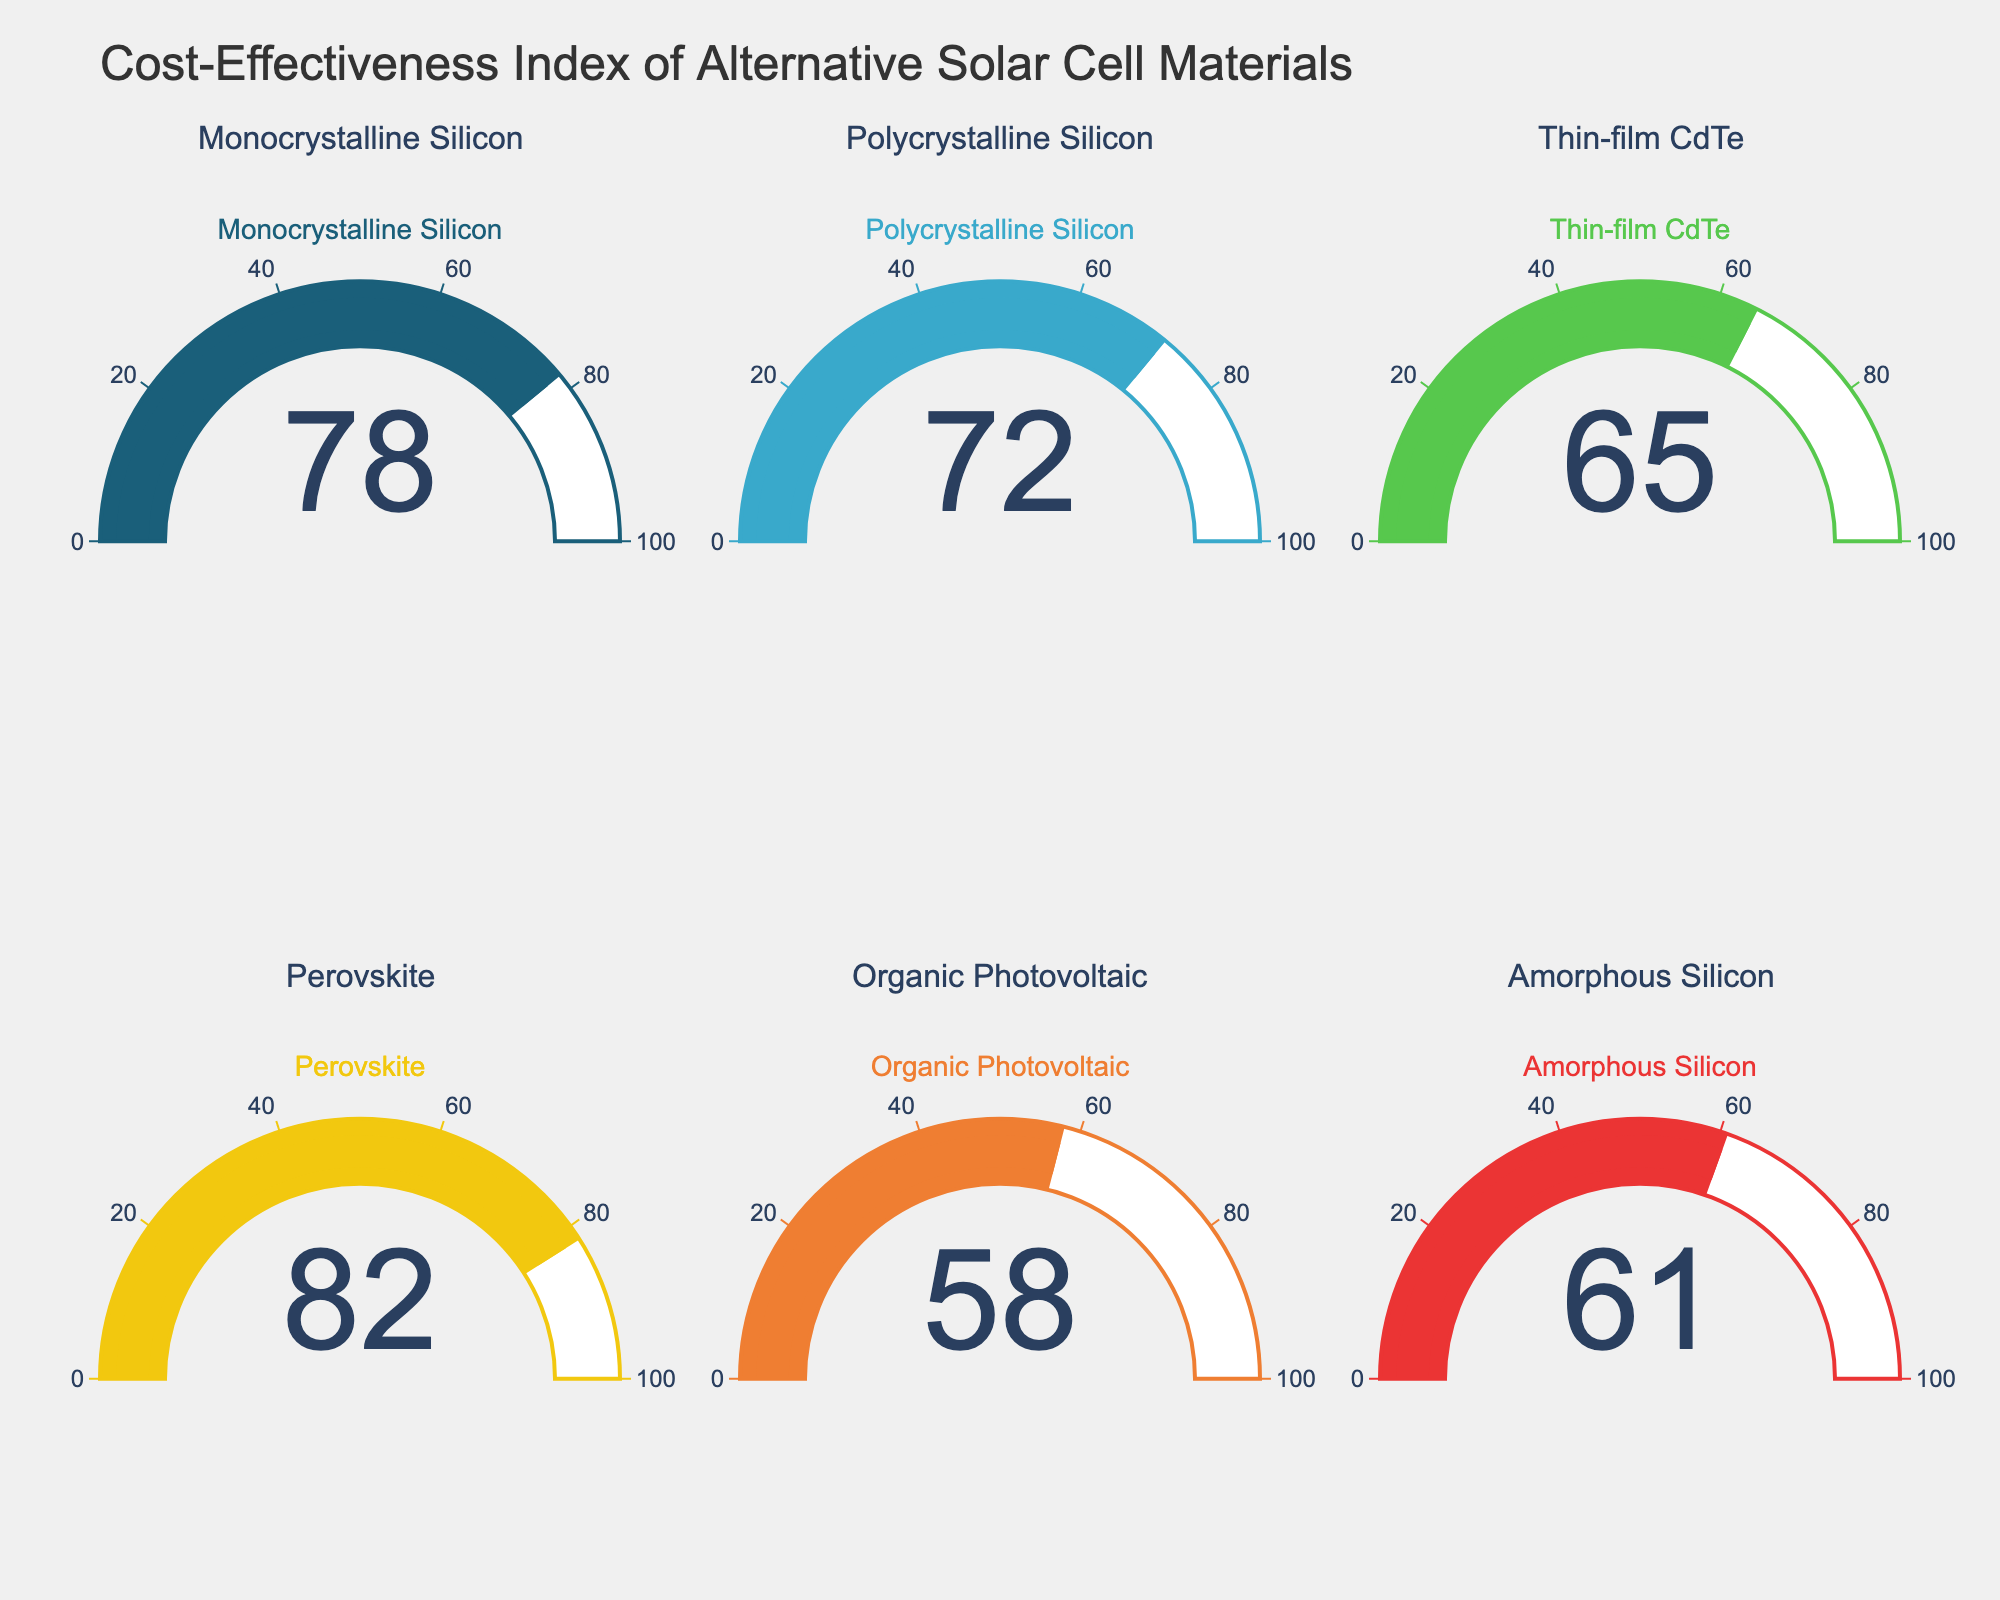What's the cost-effectiveness index of Monocrystalline Silicon? The gauge chart for Monocrystalline Silicon shows a single number which represents its cost-effectiveness index.
Answer: 78 What's the range of cost-effectiveness indices displayed in the figure? Find the minimum and maximum values from the gauge charts. Minimum is 58 (Organic Photovoltaic) and maximum is 82 (Perovskite). Therefore, the range is 82 - 58.
Answer: 24 What's the average cost-effectiveness index across all materials? Sum the indices (78 + 72 + 65 + 82 + 58 + 61) = 416, then divide by the number of materials (6). 416 / 6.
Answer: 69.33 Which material has the highest cost-effectiveness index? Identify the gauge chart with the highest number. Perovskite has the highest index of 82.
Answer: Perovskite How many materials have a cost-effectiveness index above 70? Count the number of materials with indices greater than 70. The materials are Monocrystalline Silicon, Polycrystalline Silicon, and Perovskite.
Answer: 3 What's the difference in cost-effectiveness index between Monocrystalline Silicon and Amorphous Silicon? Subtract the index of Amorphous Silicon from that of Monocrystalline Silicon. 78 - 61.
Answer: 17 Which materials have a cost-effectiveness index below 65? Identify the gauge charts with values less than 65. Organic Photovoltaic (58) and Amorphous Silicon (61) are below 65.
Answer: Organic Photovoltaic and Amorphous Silicon Rank the materials from least to most cost-effective based on the indices shown in the gauge charts. List the materials in ascending order based on their cost-effectiveness indices: Organic Photovoltaic (58), Amorphous Silicon (61), Thin-film CdTe (65), Polycrystalline Silicon (72), Monocrystalline Silicon (78), Perovskite (82).
Answer: Organic Photovoltaic, Amorphous Silicon, Thin-film CdTe, Polycrystalline Silicon, Monocrystalline Silicon, Perovskite What’s the median value of the cost-effectiveness indices? Order the cost-effectiveness indices and find the middle value(s): [58, 61, 65, 72, 78, 82]. The median is the average of the two middle values: (65 + 72) / 2.
Answer: 68.5 